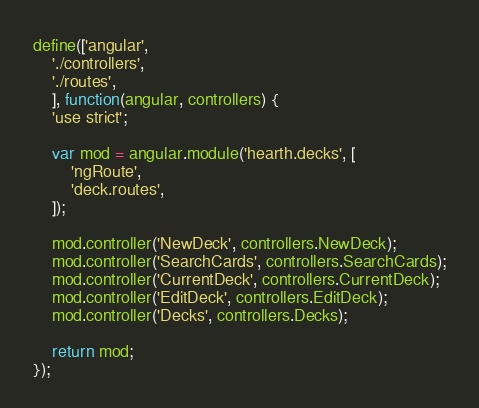<code> <loc_0><loc_0><loc_500><loc_500><_JavaScript_>define(['angular',
	'./controllers',
	'./routes',
	], function(angular, controllers) {
	'use strict';

	var mod = angular.module('hearth.decks', [
		'ngRoute',
		'deck.routes',
	]);

	mod.controller('NewDeck', controllers.NewDeck);
	mod.controller('SearchCards', controllers.SearchCards);
	mod.controller('CurrentDeck', controllers.CurrentDeck);
	mod.controller('EditDeck', controllers.EditDeck);
	mod.controller('Decks', controllers.Decks);

	return mod;
});
</code> 